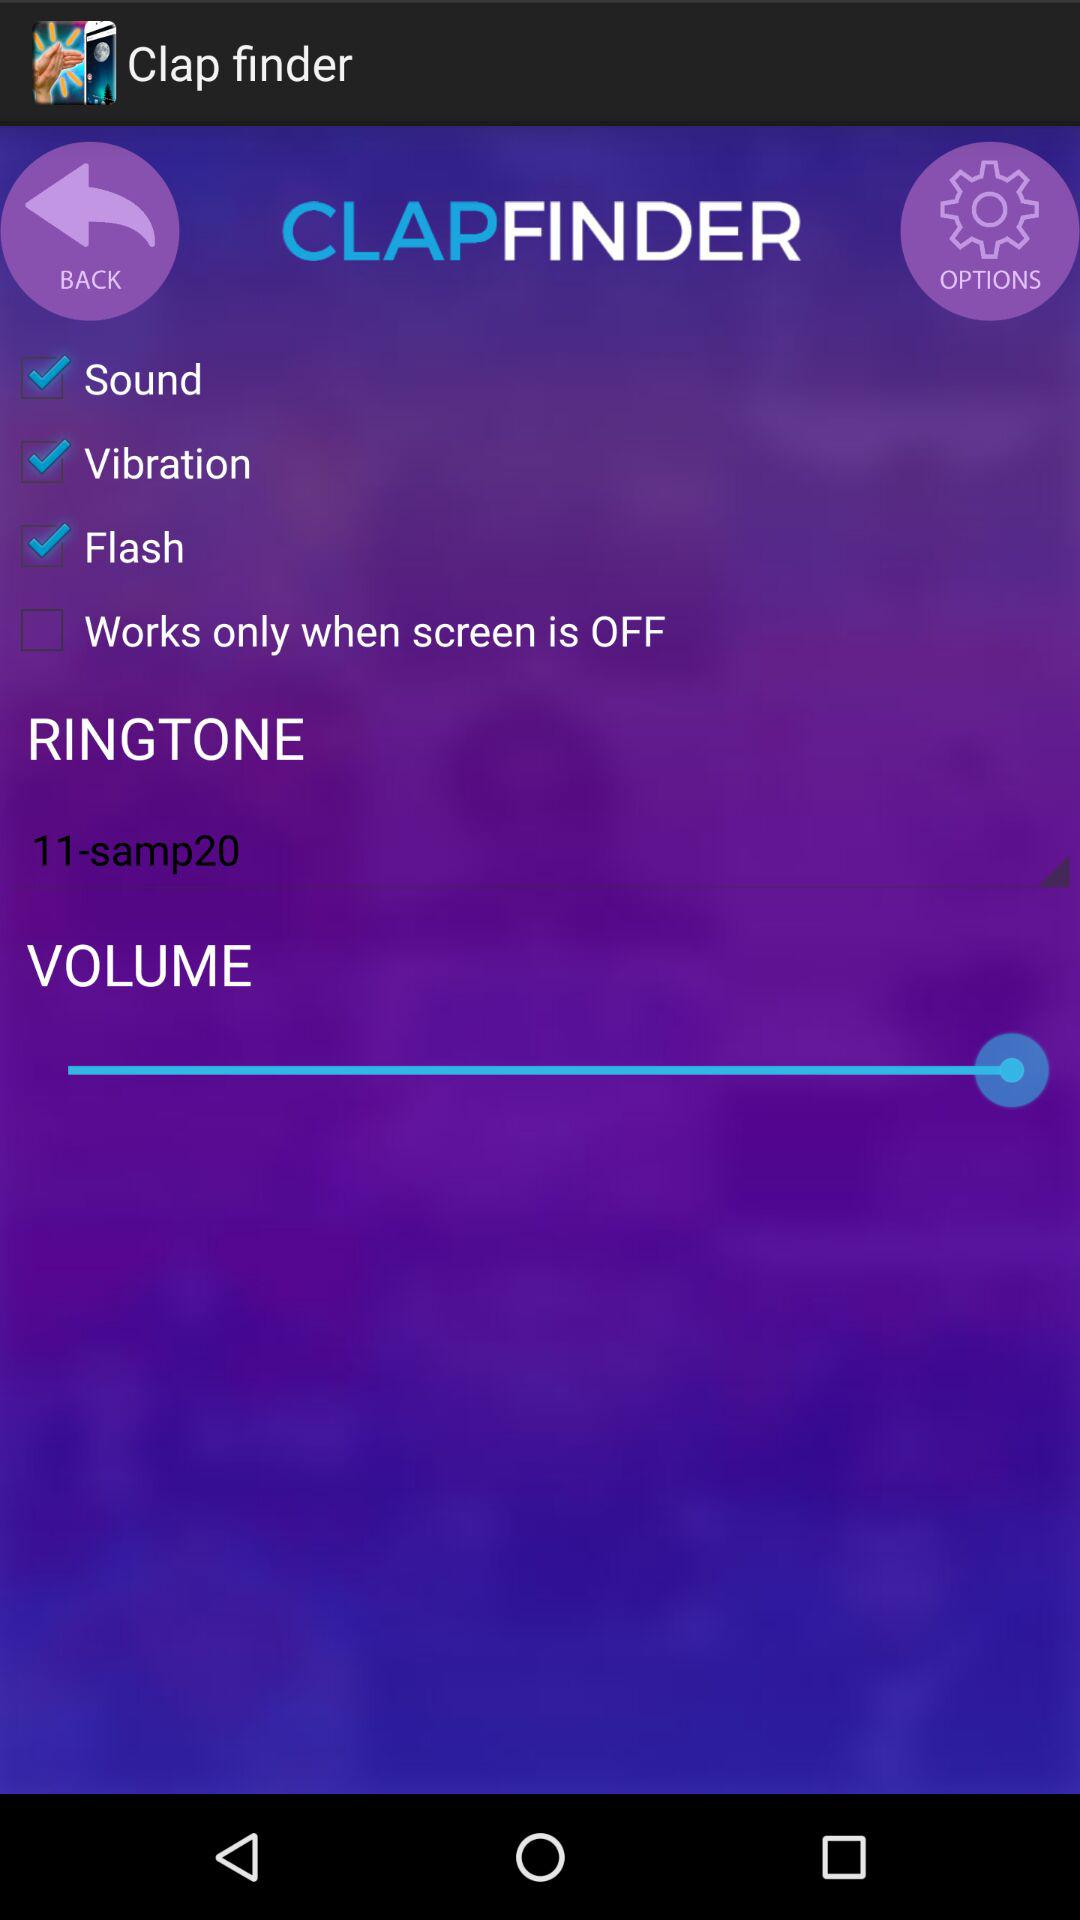How many checkboxes are there that are not labeled Works only when screen is OFF?
Answer the question using a single word or phrase. 3 